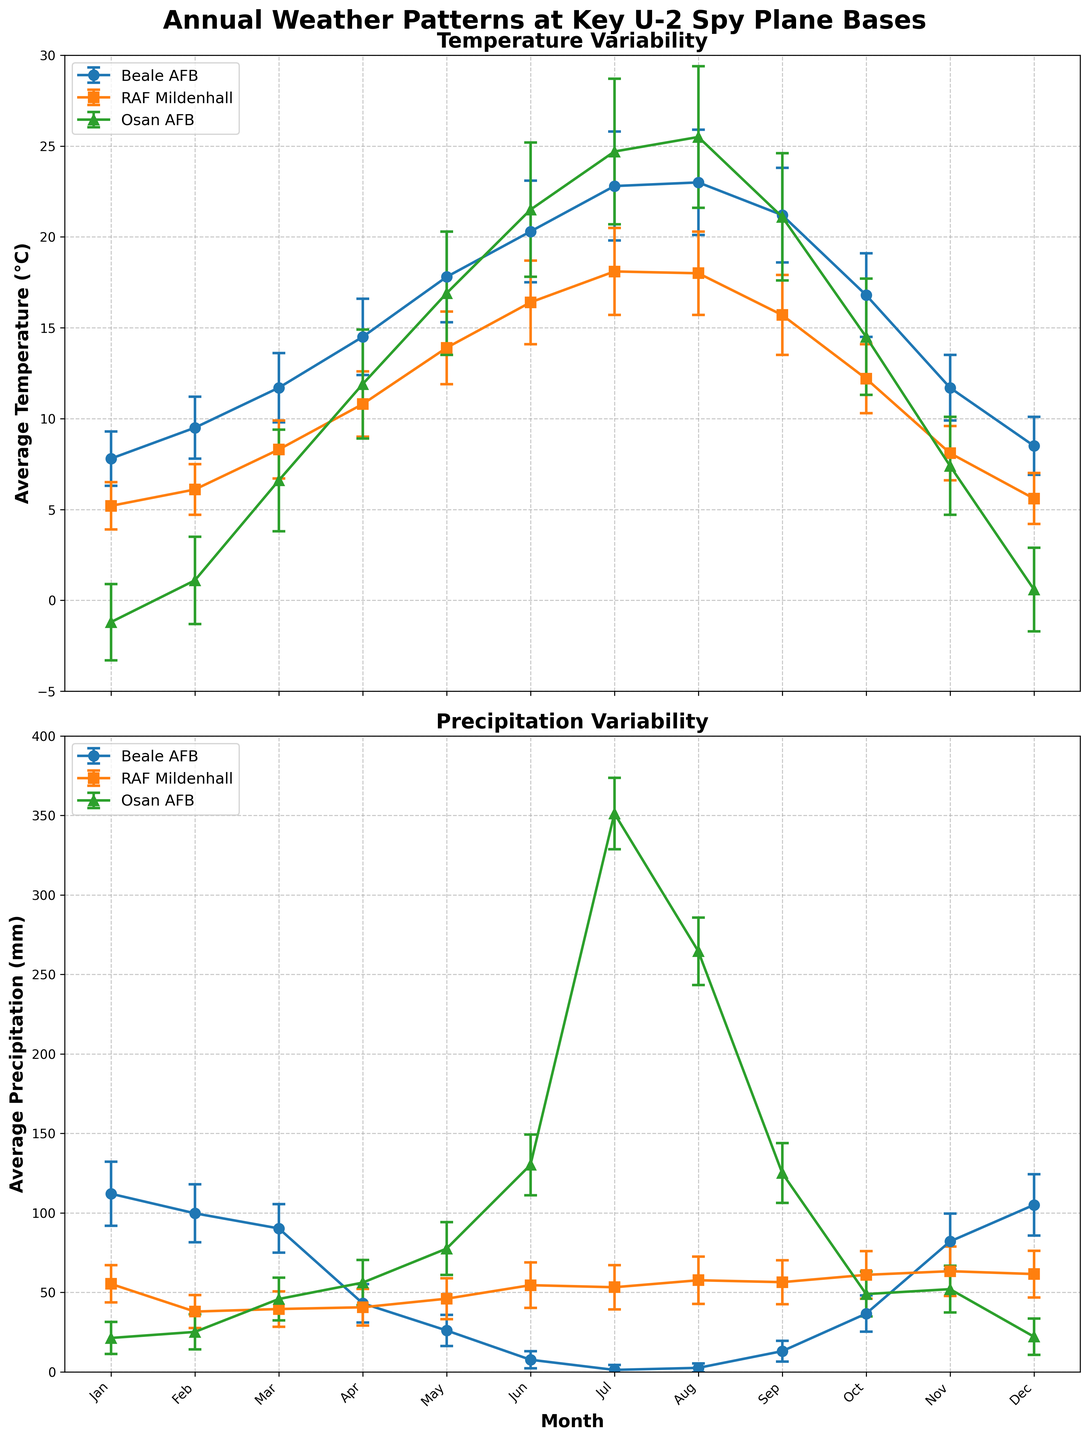What is the average temperature in January at Beale AFB? The average temperature in January at Beale AFB can be directly read from the temperature plot. Locate the point for January under Beale AFB and read the value.
Answer: 7.8°C Which base has the highest average temperature in August? To determine which base has the highest average temperature in August, look for the point corresponding to August on the temperature plot for each base and compare the temperatures.
Answer: Osan AFB What is the range of monthly average precipitation values at RAF Mildenhall? To find the range of monthly average precipitation values at RAF Mildenhall, identify the highest and lowest points on the precipitation plot for RAF Mildenhall and subtract the lowest value from the highest value.
Answer: 25.7 mm (57.6 mm - 31.9 mm) How does the temperature variability at Beale AFB compare between January and July? Compare the error bars representing the standard deviations on the temperature plot for Beale AFB in January and July. Longer error bars indicate higher variability.
Answer: More variability in July (2.9) than January (1.5) Which month has the lowest average precipitation at Osan AFB, and what is its value? To find the month with the lowest average precipitation at Osan AFB, locate the month with the lowest point on the precipitation plot for Osan AFB and read the precipitation value.
Answer: July, 1.2 mm How does precipitation in November at RAF Mildenhall compare to that at Beale AFB? To compare precipitation levels in November at RAF Mildenhall and Beale AFB, locate November on the precipitation plot for both bases and compare the values.
Answer: Beale AFB has higher precipitation During which month does Beale AFB experience its highest average temperature, and what is the temperature? Locate the point with the highest average temperature on the temperature plot for Beale AFB and identify the corresponding month and temperature value.
Answer: August, 23.0°C 